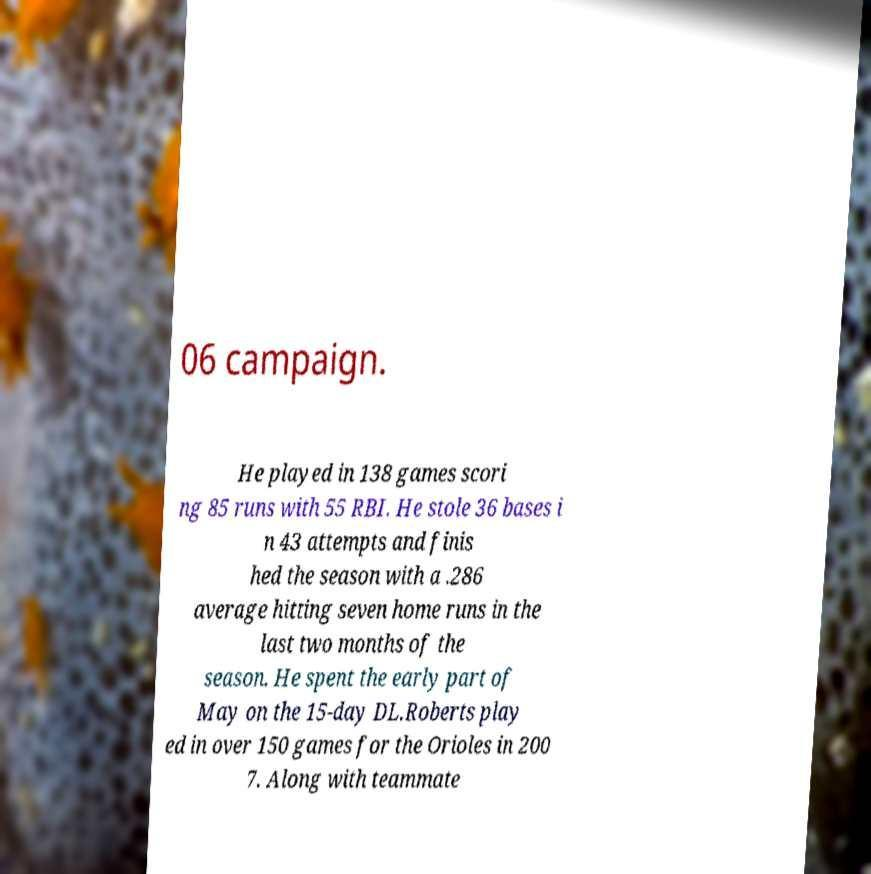I need the written content from this picture converted into text. Can you do that? 06 campaign. He played in 138 games scori ng 85 runs with 55 RBI. He stole 36 bases i n 43 attempts and finis hed the season with a .286 average hitting seven home runs in the last two months of the season. He spent the early part of May on the 15-day DL.Roberts play ed in over 150 games for the Orioles in 200 7. Along with teammate 